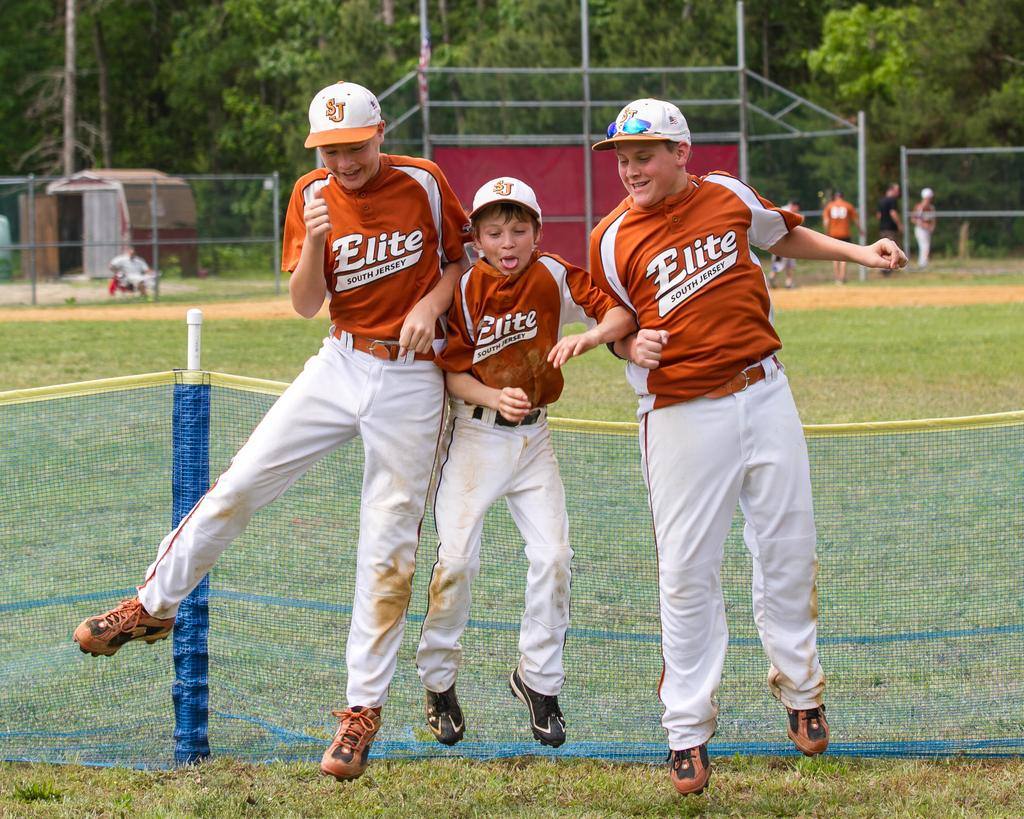<image>
Describe the image concisely. Three young Elite south jersey baseball player in red and white side by side jumping. 